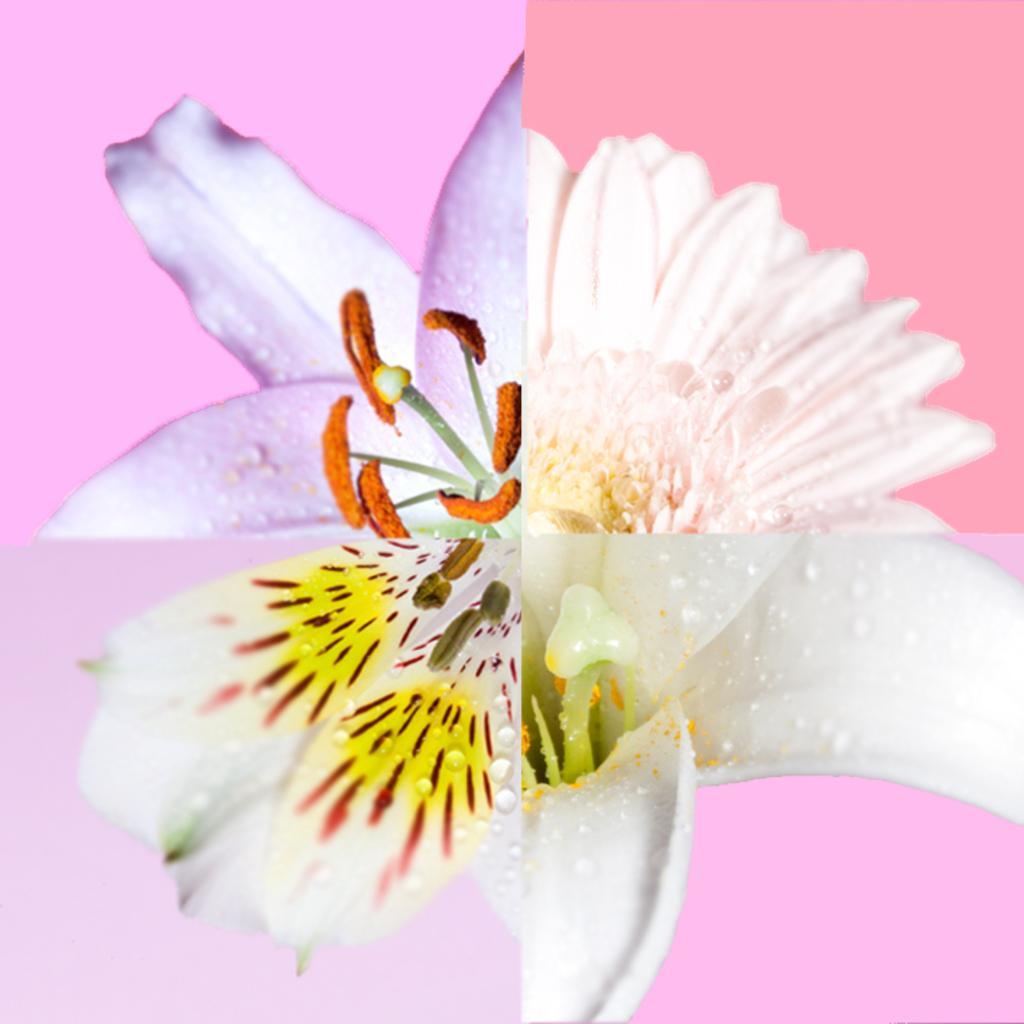Could you give a brief overview of what you see in this image? This is collage picture, in these pictures we can see flowers. In the background we can see different colors. 